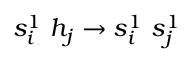Convert formula to latex. <formula><loc_0><loc_0><loc_500><loc_500>s _ { i } ^ { 1 } \ h _ { j } \to s _ { i } ^ { 1 } \ s _ { j } ^ { 1 }</formula> 